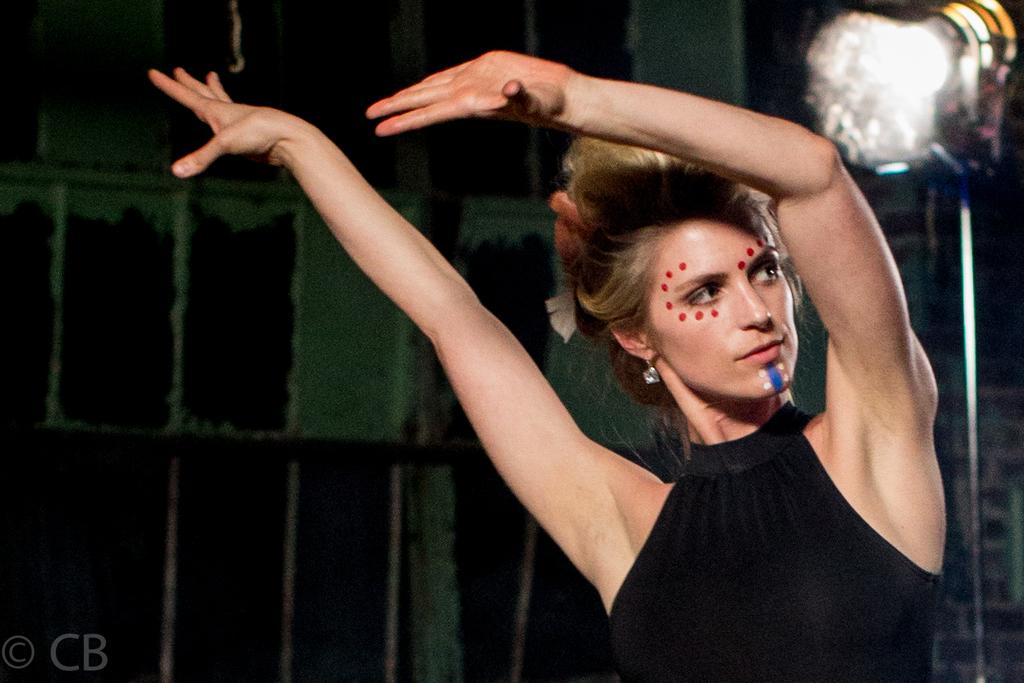Who is the main subject in the image? There is a woman in the image. What is the woman wearing? The woman is wearing a black dress. What is the woman doing in the image? The woman is dancing. What can be seen to the right of the image? There is a stand to the right of the image. What is attached to the stand? A light is fixed to the stand. What is visible in the background of the image? There is a wall in the background of the image. Where is the sofa located in the image? There is no sofa present in the image. What type of work is the woman doing in the image? The image does not show the woman doing any work; she is dancing. What is the size of the woman's brain in the image? The size of the woman's brain cannot be determined from the image, as it is not visible. 